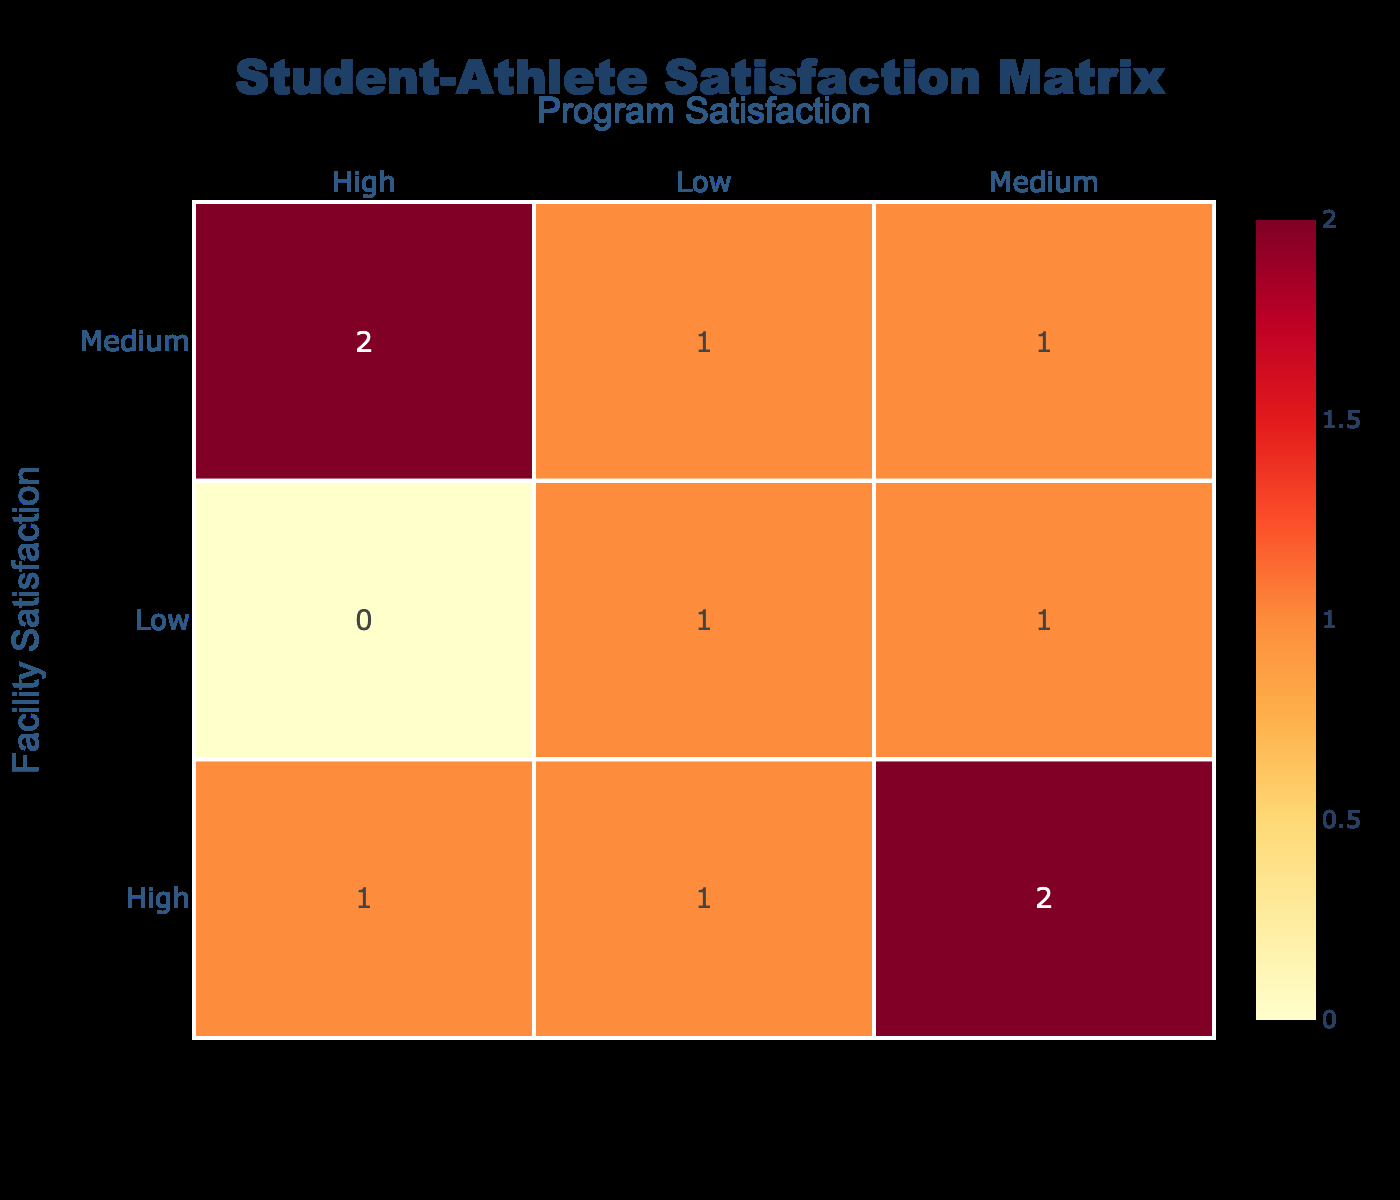What is the number of student-athletes who rated their facility satisfaction as 'High' and program satisfaction as 'Medium'? From the confusion matrix, we can look for the cell where 'Facility Satisfaction' is 'High' and 'Program Satisfaction' is 'Medium'. In that cell, the value is 3.
Answer: 3 What is the total number of student-athletes who have rated their program satisfaction as 'High'? We can sum the values in the row for 'High' under the 'Program Satisfaction' column. The values are: 1 (Swimming) + 1 (Track and Field) + 1 (Wrestling) = 3.
Answer: 3 Is there a student-athlete who rated both their facility and program satisfaction as 'Low'? To find this, we check the confusion matrix for the cell where both 'Facility Satisfaction' and 'Program Satisfaction' are 'Low'. The value in that cell is 1, indicating there is indeed one student-athlete.
Answer: Yes What is the difference in the number of student-athletes who rated their facility satisfaction as 'Medium' compared to those who rated it as 'Low'? The number of student-athletes who rated their facility satisfaction as 'Medium' is 3, and those who rated it as 'Low' is also 3. Therefore, the difference is 3 - 3 = 0.
Answer: 0 Which facility satisfaction rating had the highest count of associated program satisfaction ratings? By reviewing the confusion matrix, we can see that 'High' facility satisfaction relates to 3 student-athletes rating their programs. This is the highest count compared to the other satisfaction ratings.
Answer: High 